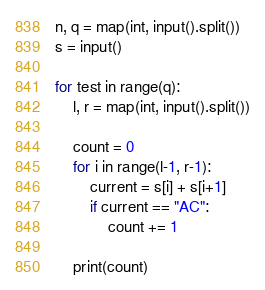Convert code to text. <code><loc_0><loc_0><loc_500><loc_500><_Python_>n, q = map(int, input().split())
s = input()

for test in range(q):
	l, r = map(int, input().split())

	count = 0
	for i in range(l-1, r-1):
		current = s[i] + s[i+1]
		if current == "AC":
			count += 1

	print(count)
</code> 